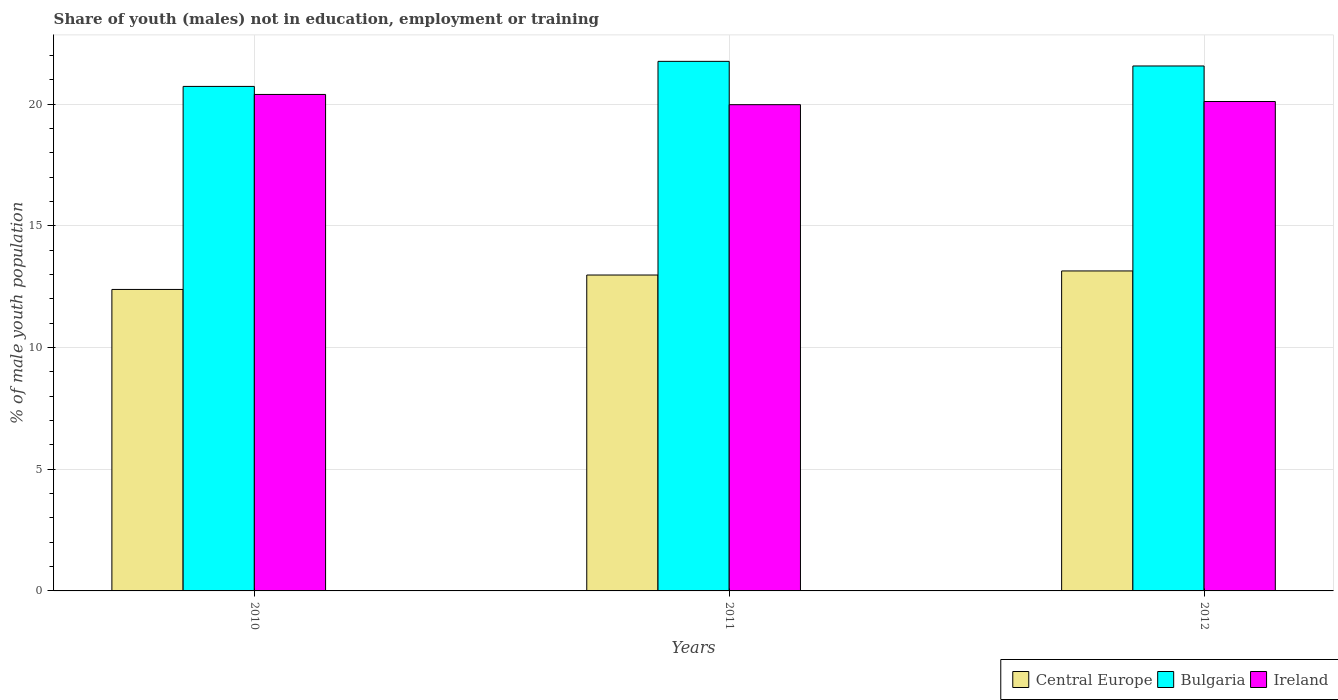How many different coloured bars are there?
Offer a very short reply. 3. Are the number of bars per tick equal to the number of legend labels?
Offer a terse response. Yes. How many bars are there on the 3rd tick from the left?
Provide a succinct answer. 3. What is the label of the 3rd group of bars from the left?
Provide a short and direct response. 2012. In how many cases, is the number of bars for a given year not equal to the number of legend labels?
Your answer should be compact. 0. What is the percentage of unemployed males population in in Ireland in 2012?
Offer a terse response. 20.11. Across all years, what is the maximum percentage of unemployed males population in in Ireland?
Offer a terse response. 20.4. Across all years, what is the minimum percentage of unemployed males population in in Central Europe?
Make the answer very short. 12.39. In which year was the percentage of unemployed males population in in Bulgaria maximum?
Make the answer very short. 2011. In which year was the percentage of unemployed males population in in Ireland minimum?
Keep it short and to the point. 2011. What is the total percentage of unemployed males population in in Ireland in the graph?
Your answer should be very brief. 60.49. What is the difference between the percentage of unemployed males population in in Central Europe in 2010 and that in 2011?
Your response must be concise. -0.59. What is the difference between the percentage of unemployed males population in in Bulgaria in 2011 and the percentage of unemployed males population in in Central Europe in 2010?
Your response must be concise. 9.37. What is the average percentage of unemployed males population in in Bulgaria per year?
Give a very brief answer. 21.35. In the year 2011, what is the difference between the percentage of unemployed males population in in Central Europe and percentage of unemployed males population in in Bulgaria?
Offer a terse response. -8.78. What is the ratio of the percentage of unemployed males population in in Central Europe in 2011 to that in 2012?
Make the answer very short. 0.99. What is the difference between the highest and the second highest percentage of unemployed males population in in Ireland?
Provide a short and direct response. 0.29. What is the difference between the highest and the lowest percentage of unemployed males population in in Central Europe?
Ensure brevity in your answer.  0.76. In how many years, is the percentage of unemployed males population in in Bulgaria greater than the average percentage of unemployed males population in in Bulgaria taken over all years?
Ensure brevity in your answer.  2. Is the sum of the percentage of unemployed males population in in Ireland in 2011 and 2012 greater than the maximum percentage of unemployed males population in in Central Europe across all years?
Ensure brevity in your answer.  Yes. What does the 1st bar from the left in 2010 represents?
Your answer should be very brief. Central Europe. What does the 1st bar from the right in 2010 represents?
Your answer should be very brief. Ireland. Is it the case that in every year, the sum of the percentage of unemployed males population in in Bulgaria and percentage of unemployed males population in in Central Europe is greater than the percentage of unemployed males population in in Ireland?
Your answer should be compact. Yes. Are all the bars in the graph horizontal?
Offer a very short reply. No. What is the difference between two consecutive major ticks on the Y-axis?
Your answer should be compact. 5. Are the values on the major ticks of Y-axis written in scientific E-notation?
Ensure brevity in your answer.  No. Does the graph contain grids?
Provide a short and direct response. Yes. What is the title of the graph?
Give a very brief answer. Share of youth (males) not in education, employment or training. What is the label or title of the Y-axis?
Provide a succinct answer. % of male youth population. What is the % of male youth population of Central Europe in 2010?
Your response must be concise. 12.39. What is the % of male youth population of Bulgaria in 2010?
Provide a short and direct response. 20.73. What is the % of male youth population in Ireland in 2010?
Offer a terse response. 20.4. What is the % of male youth population of Central Europe in 2011?
Provide a short and direct response. 12.98. What is the % of male youth population in Bulgaria in 2011?
Make the answer very short. 21.76. What is the % of male youth population of Ireland in 2011?
Your response must be concise. 19.98. What is the % of male youth population of Central Europe in 2012?
Your answer should be compact. 13.15. What is the % of male youth population in Bulgaria in 2012?
Give a very brief answer. 21.57. What is the % of male youth population in Ireland in 2012?
Keep it short and to the point. 20.11. Across all years, what is the maximum % of male youth population in Central Europe?
Your response must be concise. 13.15. Across all years, what is the maximum % of male youth population of Bulgaria?
Keep it short and to the point. 21.76. Across all years, what is the maximum % of male youth population in Ireland?
Provide a short and direct response. 20.4. Across all years, what is the minimum % of male youth population in Central Europe?
Offer a terse response. 12.39. Across all years, what is the minimum % of male youth population in Bulgaria?
Keep it short and to the point. 20.73. Across all years, what is the minimum % of male youth population of Ireland?
Keep it short and to the point. 19.98. What is the total % of male youth population in Central Europe in the graph?
Your answer should be very brief. 38.52. What is the total % of male youth population of Bulgaria in the graph?
Keep it short and to the point. 64.06. What is the total % of male youth population in Ireland in the graph?
Make the answer very short. 60.49. What is the difference between the % of male youth population in Central Europe in 2010 and that in 2011?
Ensure brevity in your answer.  -0.59. What is the difference between the % of male youth population of Bulgaria in 2010 and that in 2011?
Offer a terse response. -1.03. What is the difference between the % of male youth population in Ireland in 2010 and that in 2011?
Make the answer very short. 0.42. What is the difference between the % of male youth population in Central Europe in 2010 and that in 2012?
Make the answer very short. -0.76. What is the difference between the % of male youth population in Bulgaria in 2010 and that in 2012?
Provide a succinct answer. -0.84. What is the difference between the % of male youth population in Ireland in 2010 and that in 2012?
Offer a terse response. 0.29. What is the difference between the % of male youth population in Central Europe in 2011 and that in 2012?
Ensure brevity in your answer.  -0.17. What is the difference between the % of male youth population in Bulgaria in 2011 and that in 2012?
Offer a very short reply. 0.19. What is the difference between the % of male youth population of Ireland in 2011 and that in 2012?
Offer a terse response. -0.13. What is the difference between the % of male youth population of Central Europe in 2010 and the % of male youth population of Bulgaria in 2011?
Make the answer very short. -9.37. What is the difference between the % of male youth population in Central Europe in 2010 and the % of male youth population in Ireland in 2011?
Provide a succinct answer. -7.59. What is the difference between the % of male youth population of Central Europe in 2010 and the % of male youth population of Bulgaria in 2012?
Make the answer very short. -9.18. What is the difference between the % of male youth population in Central Europe in 2010 and the % of male youth population in Ireland in 2012?
Your answer should be compact. -7.72. What is the difference between the % of male youth population in Bulgaria in 2010 and the % of male youth population in Ireland in 2012?
Make the answer very short. 0.62. What is the difference between the % of male youth population of Central Europe in 2011 and the % of male youth population of Bulgaria in 2012?
Offer a very short reply. -8.59. What is the difference between the % of male youth population of Central Europe in 2011 and the % of male youth population of Ireland in 2012?
Offer a terse response. -7.13. What is the difference between the % of male youth population in Bulgaria in 2011 and the % of male youth population in Ireland in 2012?
Your answer should be very brief. 1.65. What is the average % of male youth population in Central Europe per year?
Ensure brevity in your answer.  12.84. What is the average % of male youth population of Bulgaria per year?
Keep it short and to the point. 21.35. What is the average % of male youth population of Ireland per year?
Give a very brief answer. 20.16. In the year 2010, what is the difference between the % of male youth population in Central Europe and % of male youth population in Bulgaria?
Your answer should be compact. -8.34. In the year 2010, what is the difference between the % of male youth population of Central Europe and % of male youth population of Ireland?
Give a very brief answer. -8.01. In the year 2010, what is the difference between the % of male youth population in Bulgaria and % of male youth population in Ireland?
Your answer should be compact. 0.33. In the year 2011, what is the difference between the % of male youth population of Central Europe and % of male youth population of Bulgaria?
Ensure brevity in your answer.  -8.78. In the year 2011, what is the difference between the % of male youth population of Central Europe and % of male youth population of Ireland?
Your response must be concise. -7. In the year 2011, what is the difference between the % of male youth population in Bulgaria and % of male youth population in Ireland?
Offer a very short reply. 1.78. In the year 2012, what is the difference between the % of male youth population of Central Europe and % of male youth population of Bulgaria?
Offer a very short reply. -8.42. In the year 2012, what is the difference between the % of male youth population of Central Europe and % of male youth population of Ireland?
Offer a very short reply. -6.96. In the year 2012, what is the difference between the % of male youth population in Bulgaria and % of male youth population in Ireland?
Your response must be concise. 1.46. What is the ratio of the % of male youth population in Central Europe in 2010 to that in 2011?
Ensure brevity in your answer.  0.95. What is the ratio of the % of male youth population of Bulgaria in 2010 to that in 2011?
Your answer should be compact. 0.95. What is the ratio of the % of male youth population of Central Europe in 2010 to that in 2012?
Offer a terse response. 0.94. What is the ratio of the % of male youth population of Bulgaria in 2010 to that in 2012?
Make the answer very short. 0.96. What is the ratio of the % of male youth population of Ireland in 2010 to that in 2012?
Your answer should be compact. 1.01. What is the ratio of the % of male youth population in Central Europe in 2011 to that in 2012?
Ensure brevity in your answer.  0.99. What is the ratio of the % of male youth population in Bulgaria in 2011 to that in 2012?
Your response must be concise. 1.01. What is the ratio of the % of male youth population of Ireland in 2011 to that in 2012?
Your response must be concise. 0.99. What is the difference between the highest and the second highest % of male youth population of Central Europe?
Your answer should be compact. 0.17. What is the difference between the highest and the second highest % of male youth population of Bulgaria?
Your answer should be compact. 0.19. What is the difference between the highest and the second highest % of male youth population in Ireland?
Your answer should be very brief. 0.29. What is the difference between the highest and the lowest % of male youth population in Central Europe?
Make the answer very short. 0.76. What is the difference between the highest and the lowest % of male youth population of Ireland?
Your response must be concise. 0.42. 